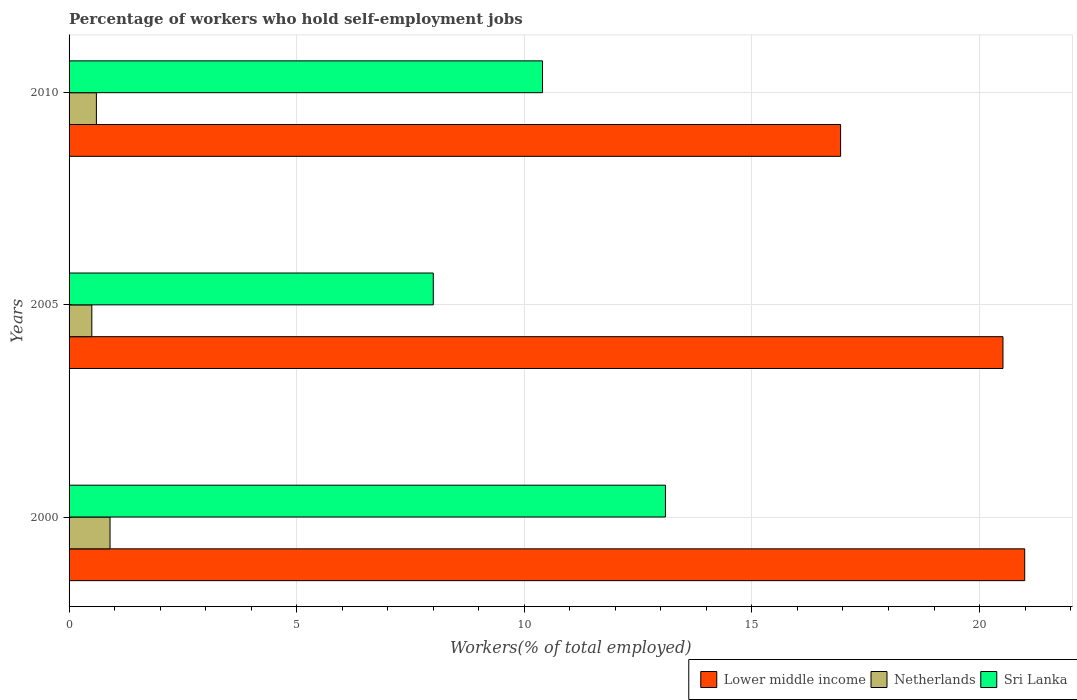Are the number of bars on each tick of the Y-axis equal?
Ensure brevity in your answer.  Yes. What is the label of the 3rd group of bars from the top?
Provide a short and direct response. 2000. In how many cases, is the number of bars for a given year not equal to the number of legend labels?
Your response must be concise. 0. What is the percentage of self-employed workers in Sri Lanka in 2005?
Offer a very short reply. 8. Across all years, what is the maximum percentage of self-employed workers in Lower middle income?
Provide a short and direct response. 20.99. Across all years, what is the minimum percentage of self-employed workers in Netherlands?
Offer a very short reply. 0.5. In which year was the percentage of self-employed workers in Lower middle income maximum?
Make the answer very short. 2000. What is the difference between the percentage of self-employed workers in Netherlands in 2000 and that in 2005?
Ensure brevity in your answer.  0.4. What is the difference between the percentage of self-employed workers in Lower middle income in 2005 and the percentage of self-employed workers in Netherlands in 2000?
Provide a short and direct response. 19.61. What is the average percentage of self-employed workers in Lower middle income per year?
Make the answer very short. 19.48. What is the ratio of the percentage of self-employed workers in Lower middle income in 2005 to that in 2010?
Give a very brief answer. 1.21. Is the percentage of self-employed workers in Netherlands in 2000 less than that in 2005?
Offer a very short reply. No. What is the difference between the highest and the second highest percentage of self-employed workers in Netherlands?
Provide a succinct answer. 0.3. What is the difference between the highest and the lowest percentage of self-employed workers in Lower middle income?
Offer a very short reply. 4.04. Is the sum of the percentage of self-employed workers in Lower middle income in 2000 and 2005 greater than the maximum percentage of self-employed workers in Sri Lanka across all years?
Offer a very short reply. Yes. What does the 1st bar from the top in 2000 represents?
Make the answer very short. Sri Lanka. What does the 3rd bar from the bottom in 2005 represents?
Keep it short and to the point. Sri Lanka. Are all the bars in the graph horizontal?
Your answer should be compact. Yes. Where does the legend appear in the graph?
Provide a short and direct response. Bottom right. What is the title of the graph?
Your response must be concise. Percentage of workers who hold self-employment jobs. Does "Australia" appear as one of the legend labels in the graph?
Ensure brevity in your answer.  No. What is the label or title of the X-axis?
Your answer should be compact. Workers(% of total employed). What is the Workers(% of total employed) of Lower middle income in 2000?
Make the answer very short. 20.99. What is the Workers(% of total employed) in Netherlands in 2000?
Provide a short and direct response. 0.9. What is the Workers(% of total employed) in Sri Lanka in 2000?
Keep it short and to the point. 13.1. What is the Workers(% of total employed) in Lower middle income in 2005?
Give a very brief answer. 20.51. What is the Workers(% of total employed) in Netherlands in 2005?
Your answer should be compact. 0.5. What is the Workers(% of total employed) of Lower middle income in 2010?
Provide a succinct answer. 16.95. What is the Workers(% of total employed) in Netherlands in 2010?
Give a very brief answer. 0.6. What is the Workers(% of total employed) of Sri Lanka in 2010?
Your response must be concise. 10.4. Across all years, what is the maximum Workers(% of total employed) of Lower middle income?
Make the answer very short. 20.99. Across all years, what is the maximum Workers(% of total employed) of Netherlands?
Provide a short and direct response. 0.9. Across all years, what is the maximum Workers(% of total employed) of Sri Lanka?
Give a very brief answer. 13.1. Across all years, what is the minimum Workers(% of total employed) of Lower middle income?
Provide a succinct answer. 16.95. Across all years, what is the minimum Workers(% of total employed) in Netherlands?
Keep it short and to the point. 0.5. What is the total Workers(% of total employed) of Lower middle income in the graph?
Ensure brevity in your answer.  58.45. What is the total Workers(% of total employed) in Sri Lanka in the graph?
Provide a succinct answer. 31.5. What is the difference between the Workers(% of total employed) in Lower middle income in 2000 and that in 2005?
Offer a terse response. 0.48. What is the difference between the Workers(% of total employed) of Lower middle income in 2000 and that in 2010?
Provide a succinct answer. 4.04. What is the difference between the Workers(% of total employed) in Sri Lanka in 2000 and that in 2010?
Your answer should be compact. 2.7. What is the difference between the Workers(% of total employed) in Lower middle income in 2005 and that in 2010?
Offer a very short reply. 3.57. What is the difference between the Workers(% of total employed) in Netherlands in 2005 and that in 2010?
Your response must be concise. -0.1. What is the difference between the Workers(% of total employed) of Sri Lanka in 2005 and that in 2010?
Your answer should be very brief. -2.4. What is the difference between the Workers(% of total employed) in Lower middle income in 2000 and the Workers(% of total employed) in Netherlands in 2005?
Provide a succinct answer. 20.49. What is the difference between the Workers(% of total employed) in Lower middle income in 2000 and the Workers(% of total employed) in Sri Lanka in 2005?
Keep it short and to the point. 12.99. What is the difference between the Workers(% of total employed) of Lower middle income in 2000 and the Workers(% of total employed) of Netherlands in 2010?
Your answer should be very brief. 20.39. What is the difference between the Workers(% of total employed) in Lower middle income in 2000 and the Workers(% of total employed) in Sri Lanka in 2010?
Your response must be concise. 10.59. What is the difference between the Workers(% of total employed) in Netherlands in 2000 and the Workers(% of total employed) in Sri Lanka in 2010?
Keep it short and to the point. -9.5. What is the difference between the Workers(% of total employed) in Lower middle income in 2005 and the Workers(% of total employed) in Netherlands in 2010?
Offer a very short reply. 19.91. What is the difference between the Workers(% of total employed) of Lower middle income in 2005 and the Workers(% of total employed) of Sri Lanka in 2010?
Offer a terse response. 10.11. What is the difference between the Workers(% of total employed) in Netherlands in 2005 and the Workers(% of total employed) in Sri Lanka in 2010?
Offer a terse response. -9.9. What is the average Workers(% of total employed) in Lower middle income per year?
Your response must be concise. 19.48. In the year 2000, what is the difference between the Workers(% of total employed) of Lower middle income and Workers(% of total employed) of Netherlands?
Your answer should be compact. 20.09. In the year 2000, what is the difference between the Workers(% of total employed) in Lower middle income and Workers(% of total employed) in Sri Lanka?
Give a very brief answer. 7.89. In the year 2000, what is the difference between the Workers(% of total employed) of Netherlands and Workers(% of total employed) of Sri Lanka?
Ensure brevity in your answer.  -12.2. In the year 2005, what is the difference between the Workers(% of total employed) of Lower middle income and Workers(% of total employed) of Netherlands?
Your response must be concise. 20.01. In the year 2005, what is the difference between the Workers(% of total employed) in Lower middle income and Workers(% of total employed) in Sri Lanka?
Offer a terse response. 12.51. In the year 2010, what is the difference between the Workers(% of total employed) of Lower middle income and Workers(% of total employed) of Netherlands?
Give a very brief answer. 16.35. In the year 2010, what is the difference between the Workers(% of total employed) of Lower middle income and Workers(% of total employed) of Sri Lanka?
Offer a very short reply. 6.55. In the year 2010, what is the difference between the Workers(% of total employed) in Netherlands and Workers(% of total employed) in Sri Lanka?
Ensure brevity in your answer.  -9.8. What is the ratio of the Workers(% of total employed) of Lower middle income in 2000 to that in 2005?
Your response must be concise. 1.02. What is the ratio of the Workers(% of total employed) of Sri Lanka in 2000 to that in 2005?
Provide a short and direct response. 1.64. What is the ratio of the Workers(% of total employed) in Lower middle income in 2000 to that in 2010?
Provide a succinct answer. 1.24. What is the ratio of the Workers(% of total employed) in Netherlands in 2000 to that in 2010?
Your response must be concise. 1.5. What is the ratio of the Workers(% of total employed) of Sri Lanka in 2000 to that in 2010?
Make the answer very short. 1.26. What is the ratio of the Workers(% of total employed) of Lower middle income in 2005 to that in 2010?
Keep it short and to the point. 1.21. What is the ratio of the Workers(% of total employed) in Sri Lanka in 2005 to that in 2010?
Provide a short and direct response. 0.77. What is the difference between the highest and the second highest Workers(% of total employed) of Lower middle income?
Your response must be concise. 0.48. What is the difference between the highest and the second highest Workers(% of total employed) in Sri Lanka?
Provide a succinct answer. 2.7. What is the difference between the highest and the lowest Workers(% of total employed) of Lower middle income?
Your response must be concise. 4.04. 